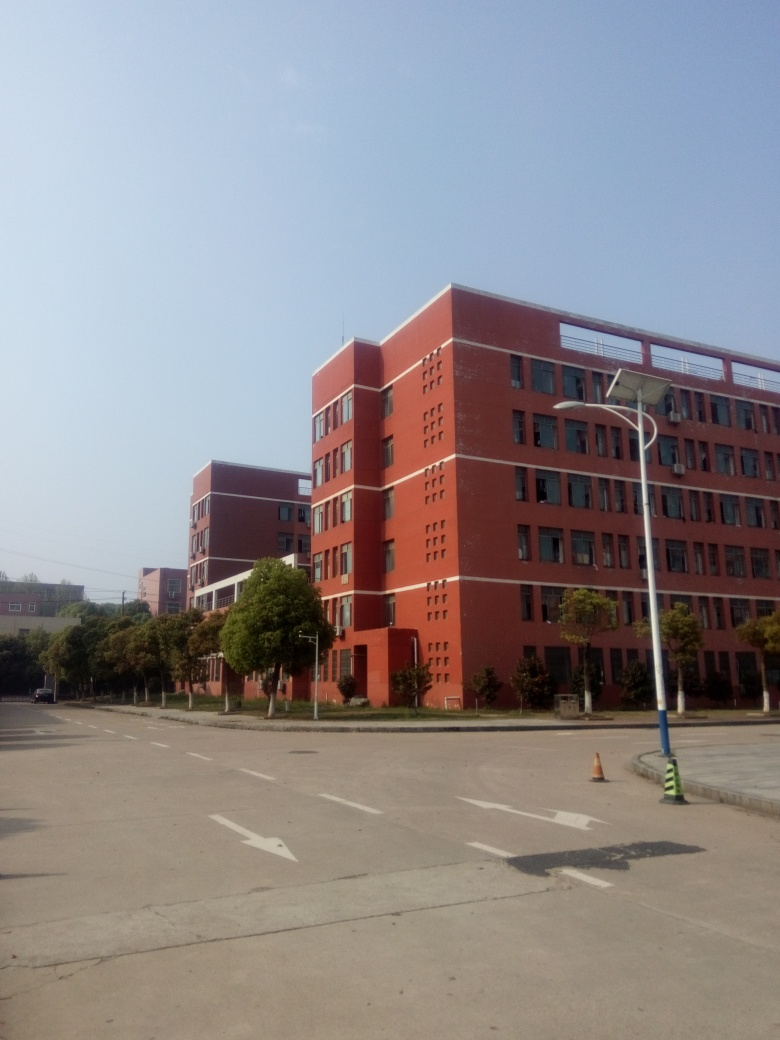Can you describe the style or architectural features of the building in the image? The building in the image exhibits a modern architectural style with a utilitarian design featuring clean lines and geometric forms. The windows are arranged in a symmetrical pattern, contributing to the facade's orderly appearance. It also appears to have multiple floors, suggesting it could be an office or academic building. 